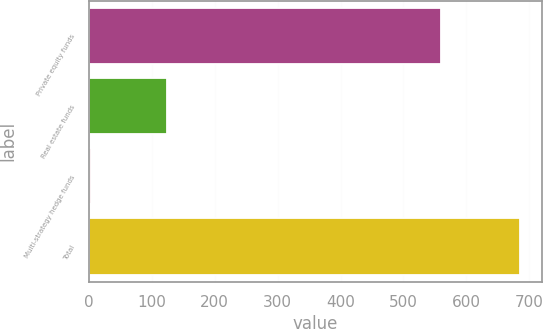Convert chart. <chart><loc_0><loc_0><loc_500><loc_500><bar_chart><fcel>Private equity funds<fcel>Real estate funds<fcel>Multi-strategy hedge funds<fcel>Total<nl><fcel>559<fcel>124<fcel>3<fcel>686<nl></chart> 